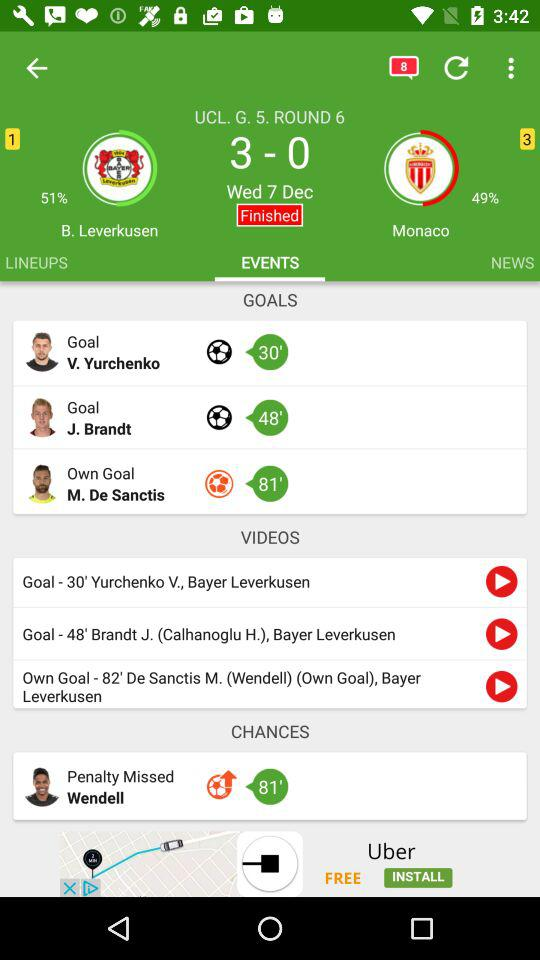What is the final score after round 6? The final score is 3 - 0. 